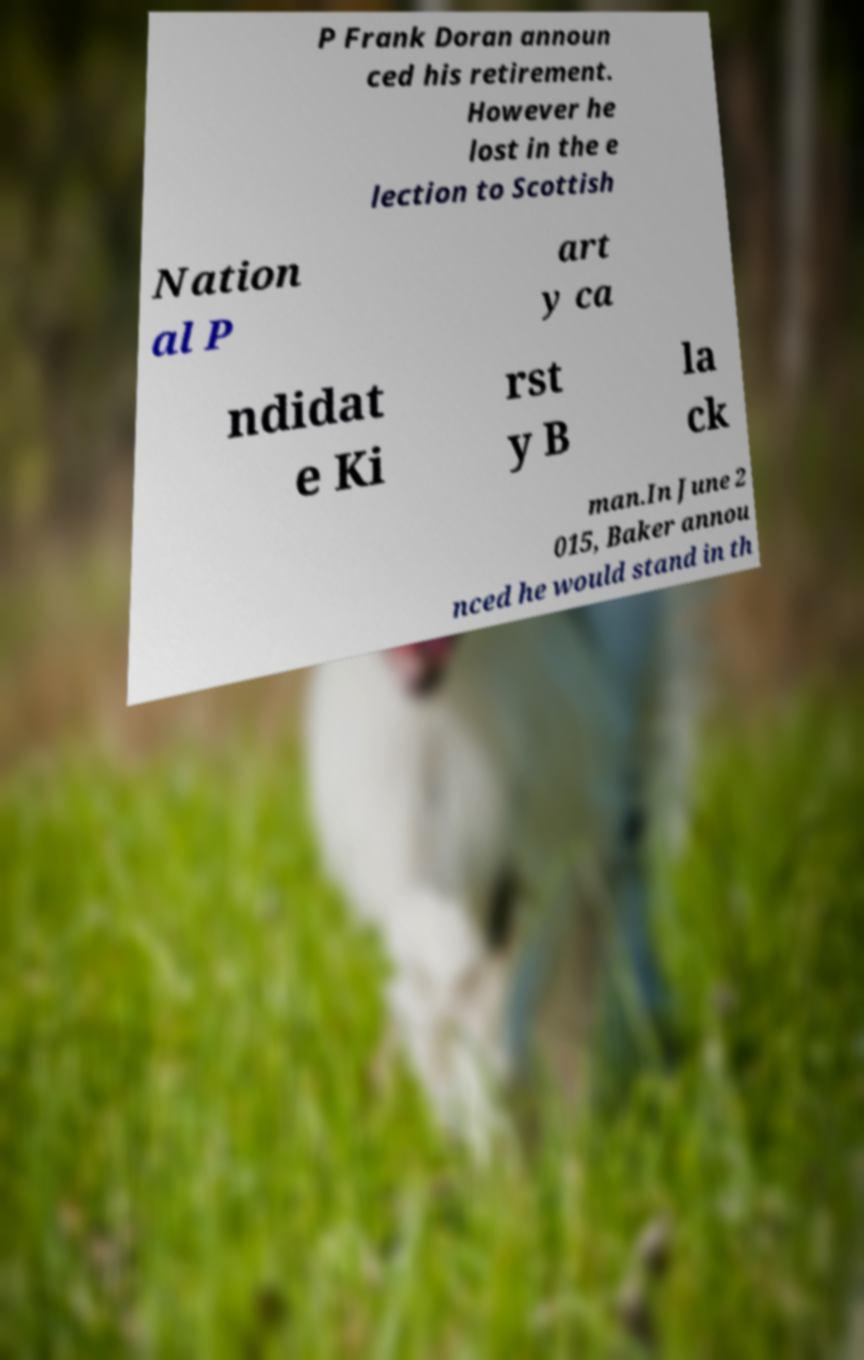What messages or text are displayed in this image? I need them in a readable, typed format. P Frank Doran announ ced his retirement. However he lost in the e lection to Scottish Nation al P art y ca ndidat e Ki rst y B la ck man.In June 2 015, Baker annou nced he would stand in th 